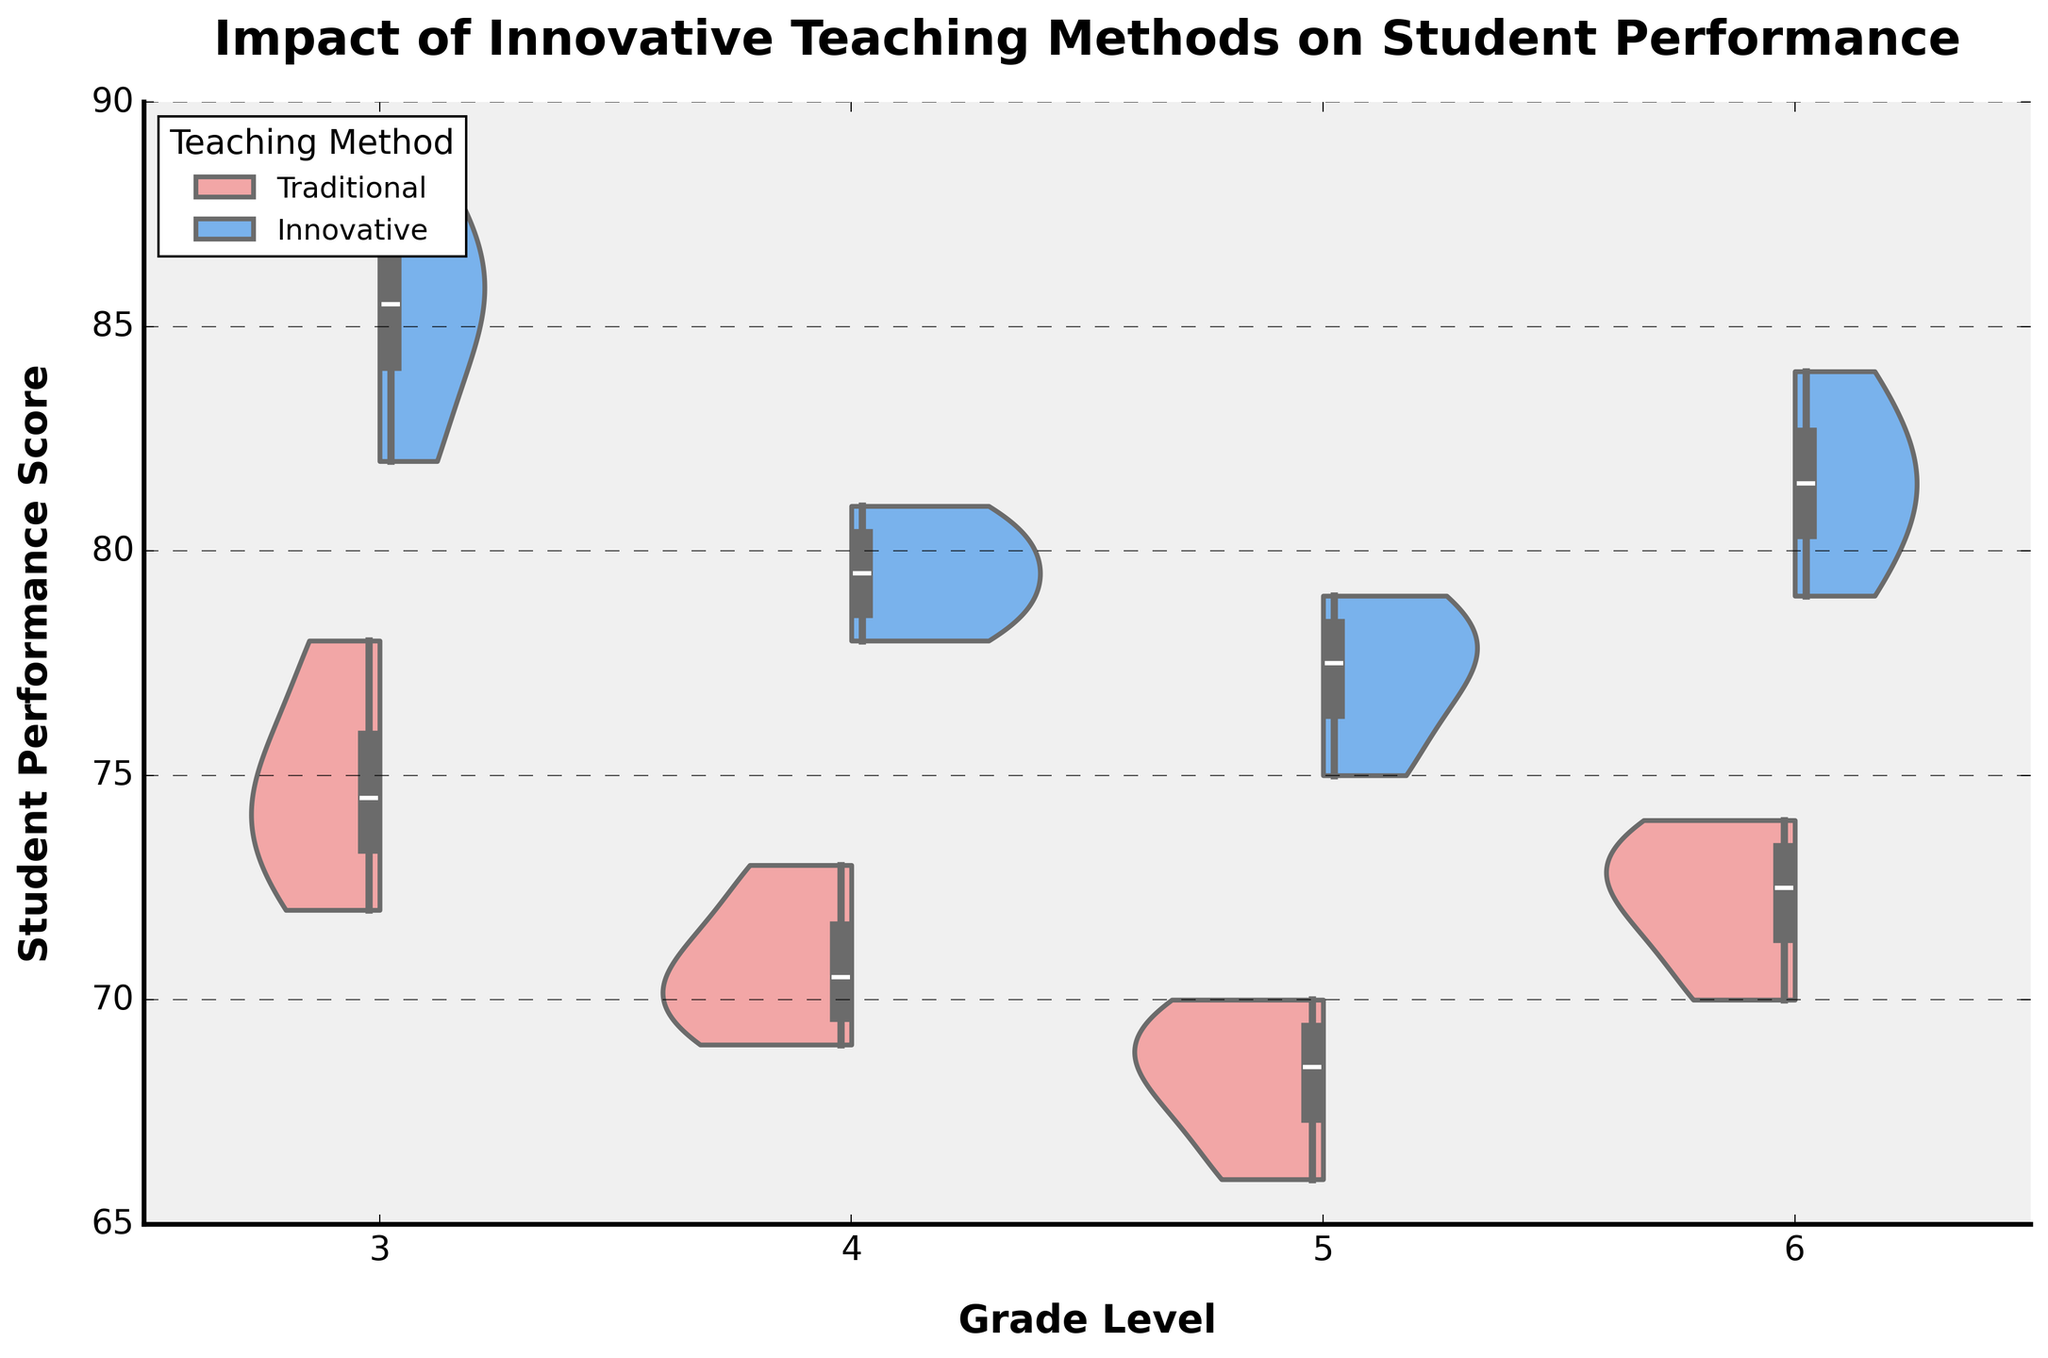What is the title of the figure? The title is displayed at the top center of the figure and reads 'Impact of Innovative Teaching Methods on Student Performance'.
Answer: Impact of Innovative Teaching Methods on Student Performance What are the grade levels shown on the x-axis? The x-axis labels indicate the grade levels present in the data, which are displayed as distinct categories.
Answer: 3, 4, 5, 6 Which teaching method appears to have higher student performance scores in Grade 3? By comparing the distributions for Grade 3, the violin plot for the Innovative method is higher, indicating better performance scores.
Answer: Innovative What is the range of student performance scores for the Traditional method in Grade 4? The Traditional method's violin plot in Grade 4 shows the spread of scores. The smallest and largest points on the violin plot indicate the range.
Answer: 69 to 73 Which grade shows the smallest difference in student performance scores between Innovative and Traditional teaching methods? By examining the visual overlap and range spans in each grade, Grade 4 has the smallest difference between the two methods' performance scores.
Answer: Grade 4 What is the median student performance score for Grade 6 using the Innovative method? The box plot overlay within the violin plot for the Innovative method in Grade 6 indicates the median value as the line inside the box.
Answer: 82.5 How does the variance in performance scores compare between the two teaching methods in Grade 5? Variance refers to the spread of scores. In Grade 5, the violin plots show that the Traditional method has a narrower spread and the Innovative method has a wider spread.
Answer: Innovative has higher variance What can be inferred about the impact of innovative teaching methods across different grade levels? By observing the violin plots, the Innovative method generally shows higher and broader distributions across all grade levels, suggesting a positive impact on student performance.
Answer: Positive impact across all grades Which teaching method in Grade 4 exhibits more consistent performance scores? The consistency is indicated by the narrowness of the violin plot. In Grade 4, the Traditional method's violin plot is narrower compared to the Innovative method, showing more consistent scores.
Answer: Traditional Are there any grade levels where the Traditional teaching method exceeds the Innovative method in student performance scores? By comparing the height and spread of the violin plots across all grades, there are no instances where Traditional outperforms the Innovative method.
Answer: No 